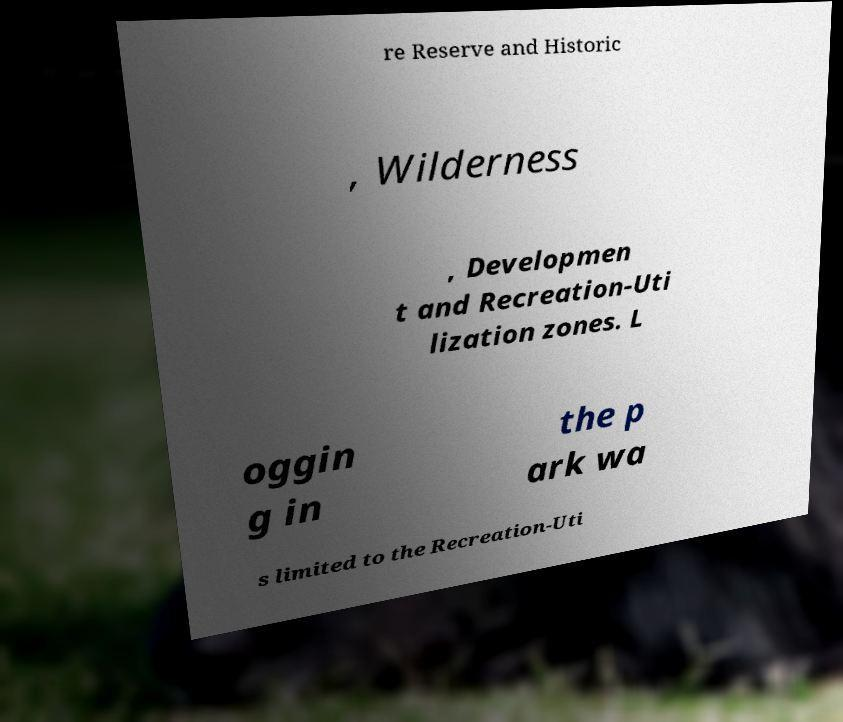Please read and relay the text visible in this image. What does it say? re Reserve and Historic , Wilderness , Developmen t and Recreation-Uti lization zones. L oggin g in the p ark wa s limited to the Recreation-Uti 